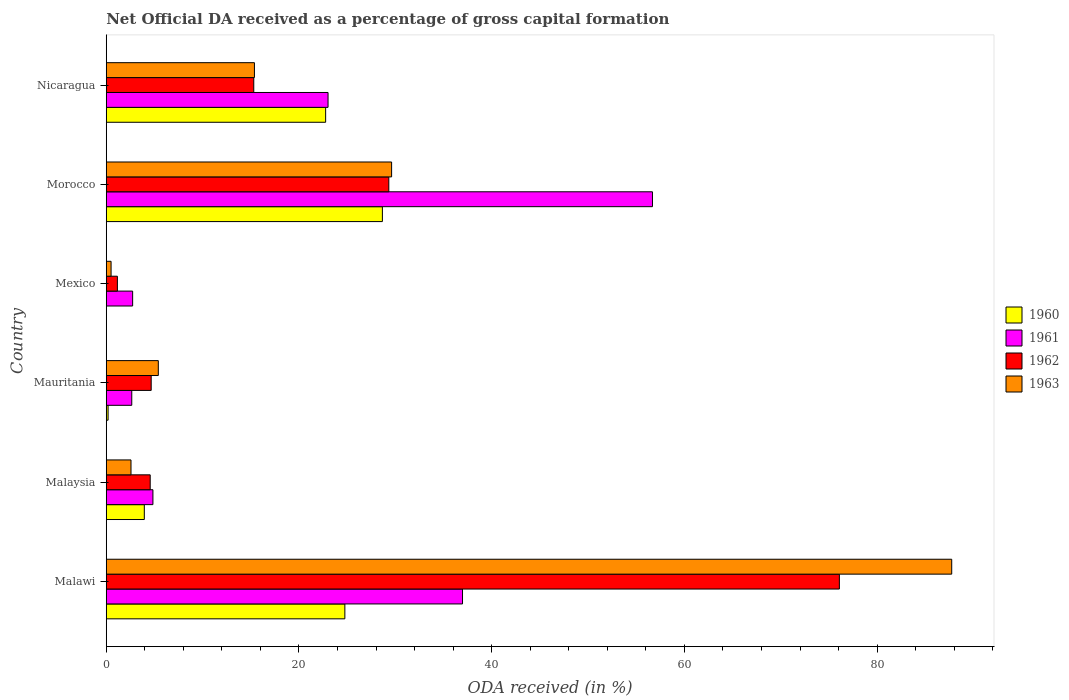How many different coloured bars are there?
Ensure brevity in your answer.  4. Are the number of bars per tick equal to the number of legend labels?
Give a very brief answer. No. What is the label of the 1st group of bars from the top?
Your answer should be very brief. Nicaragua. In how many cases, is the number of bars for a given country not equal to the number of legend labels?
Make the answer very short. 1. What is the net ODA received in 1963 in Malawi?
Provide a short and direct response. 87.74. Across all countries, what is the maximum net ODA received in 1961?
Your response must be concise. 56.69. Across all countries, what is the minimum net ODA received in 1962?
Your answer should be very brief. 1.16. In which country was the net ODA received in 1961 maximum?
Make the answer very short. Morocco. What is the total net ODA received in 1960 in the graph?
Your answer should be very brief. 80.33. What is the difference between the net ODA received in 1961 in Morocco and that in Nicaragua?
Offer a terse response. 33.67. What is the difference between the net ODA received in 1962 in Morocco and the net ODA received in 1961 in Mexico?
Provide a succinct answer. 26.59. What is the average net ODA received in 1960 per country?
Provide a succinct answer. 13.39. What is the difference between the net ODA received in 1962 and net ODA received in 1963 in Morocco?
Keep it short and to the point. -0.29. In how many countries, is the net ODA received in 1963 greater than 44 %?
Ensure brevity in your answer.  1. What is the ratio of the net ODA received in 1963 in Malawi to that in Mexico?
Your answer should be very brief. 174.93. Is the net ODA received in 1961 in Mexico less than that in Morocco?
Your answer should be compact. Yes. Is the difference between the net ODA received in 1962 in Mexico and Nicaragua greater than the difference between the net ODA received in 1963 in Mexico and Nicaragua?
Make the answer very short. Yes. What is the difference between the highest and the second highest net ODA received in 1963?
Provide a succinct answer. 58.13. What is the difference between the highest and the lowest net ODA received in 1962?
Ensure brevity in your answer.  74.92. Is it the case that in every country, the sum of the net ODA received in 1963 and net ODA received in 1962 is greater than the net ODA received in 1960?
Give a very brief answer. Yes. What is the difference between two consecutive major ticks on the X-axis?
Give a very brief answer. 20. Does the graph contain any zero values?
Your answer should be very brief. Yes. How many legend labels are there?
Your response must be concise. 4. What is the title of the graph?
Make the answer very short. Net Official DA received as a percentage of gross capital formation. What is the label or title of the X-axis?
Provide a short and direct response. ODA received (in %). What is the label or title of the Y-axis?
Offer a very short reply. Country. What is the ODA received (in %) in 1960 in Malawi?
Give a very brief answer. 24.76. What is the ODA received (in %) of 1961 in Malawi?
Make the answer very short. 36.97. What is the ODA received (in %) in 1962 in Malawi?
Your answer should be compact. 76.08. What is the ODA received (in %) of 1963 in Malawi?
Provide a short and direct response. 87.74. What is the ODA received (in %) of 1960 in Malaysia?
Your answer should be compact. 3.95. What is the ODA received (in %) of 1961 in Malaysia?
Provide a short and direct response. 4.84. What is the ODA received (in %) in 1962 in Malaysia?
Give a very brief answer. 4.56. What is the ODA received (in %) in 1963 in Malaysia?
Make the answer very short. 2.57. What is the ODA received (in %) in 1960 in Mauritania?
Offer a terse response. 0.19. What is the ODA received (in %) of 1961 in Mauritania?
Offer a very short reply. 2.65. What is the ODA received (in %) in 1962 in Mauritania?
Provide a short and direct response. 4.66. What is the ODA received (in %) in 1963 in Mauritania?
Provide a succinct answer. 5.4. What is the ODA received (in %) in 1961 in Mexico?
Provide a succinct answer. 2.74. What is the ODA received (in %) of 1962 in Mexico?
Provide a succinct answer. 1.16. What is the ODA received (in %) of 1963 in Mexico?
Ensure brevity in your answer.  0.5. What is the ODA received (in %) in 1960 in Morocco?
Ensure brevity in your answer.  28.66. What is the ODA received (in %) in 1961 in Morocco?
Provide a succinct answer. 56.69. What is the ODA received (in %) of 1962 in Morocco?
Make the answer very short. 29.32. What is the ODA received (in %) in 1963 in Morocco?
Your answer should be compact. 29.61. What is the ODA received (in %) of 1960 in Nicaragua?
Provide a short and direct response. 22.77. What is the ODA received (in %) of 1961 in Nicaragua?
Provide a succinct answer. 23.02. What is the ODA received (in %) in 1962 in Nicaragua?
Keep it short and to the point. 15.31. What is the ODA received (in %) in 1963 in Nicaragua?
Provide a short and direct response. 15.38. Across all countries, what is the maximum ODA received (in %) in 1960?
Offer a very short reply. 28.66. Across all countries, what is the maximum ODA received (in %) of 1961?
Keep it short and to the point. 56.69. Across all countries, what is the maximum ODA received (in %) of 1962?
Your answer should be very brief. 76.08. Across all countries, what is the maximum ODA received (in %) of 1963?
Provide a short and direct response. 87.74. Across all countries, what is the minimum ODA received (in %) in 1960?
Offer a terse response. 0. Across all countries, what is the minimum ODA received (in %) in 1961?
Provide a succinct answer. 2.65. Across all countries, what is the minimum ODA received (in %) of 1962?
Offer a very short reply. 1.16. Across all countries, what is the minimum ODA received (in %) of 1963?
Give a very brief answer. 0.5. What is the total ODA received (in %) of 1960 in the graph?
Ensure brevity in your answer.  80.33. What is the total ODA received (in %) of 1961 in the graph?
Make the answer very short. 126.91. What is the total ODA received (in %) of 1962 in the graph?
Offer a very short reply. 131.1. What is the total ODA received (in %) of 1963 in the graph?
Offer a very short reply. 141.21. What is the difference between the ODA received (in %) in 1960 in Malawi and that in Malaysia?
Offer a terse response. 20.81. What is the difference between the ODA received (in %) in 1961 in Malawi and that in Malaysia?
Offer a terse response. 32.13. What is the difference between the ODA received (in %) of 1962 in Malawi and that in Malaysia?
Give a very brief answer. 71.52. What is the difference between the ODA received (in %) in 1963 in Malawi and that in Malaysia?
Provide a short and direct response. 85.17. What is the difference between the ODA received (in %) in 1960 in Malawi and that in Mauritania?
Your answer should be compact. 24.57. What is the difference between the ODA received (in %) in 1961 in Malawi and that in Mauritania?
Offer a very short reply. 34.32. What is the difference between the ODA received (in %) in 1962 in Malawi and that in Mauritania?
Provide a succinct answer. 71.42. What is the difference between the ODA received (in %) of 1963 in Malawi and that in Mauritania?
Your answer should be very brief. 82.34. What is the difference between the ODA received (in %) in 1961 in Malawi and that in Mexico?
Make the answer very short. 34.23. What is the difference between the ODA received (in %) of 1962 in Malawi and that in Mexico?
Your response must be concise. 74.92. What is the difference between the ODA received (in %) in 1963 in Malawi and that in Mexico?
Offer a terse response. 87.24. What is the difference between the ODA received (in %) in 1960 in Malawi and that in Morocco?
Give a very brief answer. -3.9. What is the difference between the ODA received (in %) in 1961 in Malawi and that in Morocco?
Provide a short and direct response. -19.71. What is the difference between the ODA received (in %) in 1962 in Malawi and that in Morocco?
Provide a short and direct response. 46.76. What is the difference between the ODA received (in %) of 1963 in Malawi and that in Morocco?
Your answer should be compact. 58.13. What is the difference between the ODA received (in %) in 1960 in Malawi and that in Nicaragua?
Your response must be concise. 1.99. What is the difference between the ODA received (in %) in 1961 in Malawi and that in Nicaragua?
Keep it short and to the point. 13.96. What is the difference between the ODA received (in %) of 1962 in Malawi and that in Nicaragua?
Provide a succinct answer. 60.77. What is the difference between the ODA received (in %) of 1963 in Malawi and that in Nicaragua?
Offer a very short reply. 72.36. What is the difference between the ODA received (in %) of 1960 in Malaysia and that in Mauritania?
Offer a terse response. 3.76. What is the difference between the ODA received (in %) of 1961 in Malaysia and that in Mauritania?
Keep it short and to the point. 2.2. What is the difference between the ODA received (in %) in 1962 in Malaysia and that in Mauritania?
Your response must be concise. -0.1. What is the difference between the ODA received (in %) of 1963 in Malaysia and that in Mauritania?
Offer a very short reply. -2.83. What is the difference between the ODA received (in %) of 1961 in Malaysia and that in Mexico?
Your answer should be very brief. 2.11. What is the difference between the ODA received (in %) in 1962 in Malaysia and that in Mexico?
Ensure brevity in your answer.  3.4. What is the difference between the ODA received (in %) of 1963 in Malaysia and that in Mexico?
Offer a terse response. 2.07. What is the difference between the ODA received (in %) of 1960 in Malaysia and that in Morocco?
Your response must be concise. -24.71. What is the difference between the ODA received (in %) of 1961 in Malaysia and that in Morocco?
Your response must be concise. -51.84. What is the difference between the ODA received (in %) in 1962 in Malaysia and that in Morocco?
Your answer should be very brief. -24.76. What is the difference between the ODA received (in %) in 1963 in Malaysia and that in Morocco?
Provide a short and direct response. -27.04. What is the difference between the ODA received (in %) of 1960 in Malaysia and that in Nicaragua?
Provide a short and direct response. -18.82. What is the difference between the ODA received (in %) of 1961 in Malaysia and that in Nicaragua?
Your answer should be very brief. -18.17. What is the difference between the ODA received (in %) in 1962 in Malaysia and that in Nicaragua?
Ensure brevity in your answer.  -10.75. What is the difference between the ODA received (in %) in 1963 in Malaysia and that in Nicaragua?
Offer a very short reply. -12.81. What is the difference between the ODA received (in %) in 1961 in Mauritania and that in Mexico?
Make the answer very short. -0.09. What is the difference between the ODA received (in %) of 1962 in Mauritania and that in Mexico?
Give a very brief answer. 3.51. What is the difference between the ODA received (in %) in 1963 in Mauritania and that in Mexico?
Provide a short and direct response. 4.9. What is the difference between the ODA received (in %) of 1960 in Mauritania and that in Morocco?
Keep it short and to the point. -28.47. What is the difference between the ODA received (in %) in 1961 in Mauritania and that in Morocco?
Give a very brief answer. -54.04. What is the difference between the ODA received (in %) of 1962 in Mauritania and that in Morocco?
Give a very brief answer. -24.66. What is the difference between the ODA received (in %) of 1963 in Mauritania and that in Morocco?
Provide a succinct answer. -24.21. What is the difference between the ODA received (in %) in 1960 in Mauritania and that in Nicaragua?
Your answer should be compact. -22.58. What is the difference between the ODA received (in %) of 1961 in Mauritania and that in Nicaragua?
Offer a terse response. -20.37. What is the difference between the ODA received (in %) in 1962 in Mauritania and that in Nicaragua?
Offer a very short reply. -10.64. What is the difference between the ODA received (in %) of 1963 in Mauritania and that in Nicaragua?
Provide a succinct answer. -9.97. What is the difference between the ODA received (in %) in 1961 in Mexico and that in Morocco?
Provide a short and direct response. -53.95. What is the difference between the ODA received (in %) in 1962 in Mexico and that in Morocco?
Offer a terse response. -28.17. What is the difference between the ODA received (in %) in 1963 in Mexico and that in Morocco?
Provide a short and direct response. -29.11. What is the difference between the ODA received (in %) of 1961 in Mexico and that in Nicaragua?
Give a very brief answer. -20.28. What is the difference between the ODA received (in %) of 1962 in Mexico and that in Nicaragua?
Provide a succinct answer. -14.15. What is the difference between the ODA received (in %) in 1963 in Mexico and that in Nicaragua?
Provide a short and direct response. -14.88. What is the difference between the ODA received (in %) of 1960 in Morocco and that in Nicaragua?
Make the answer very short. 5.89. What is the difference between the ODA received (in %) of 1961 in Morocco and that in Nicaragua?
Keep it short and to the point. 33.67. What is the difference between the ODA received (in %) of 1962 in Morocco and that in Nicaragua?
Your answer should be compact. 14.02. What is the difference between the ODA received (in %) in 1963 in Morocco and that in Nicaragua?
Ensure brevity in your answer.  14.23. What is the difference between the ODA received (in %) in 1960 in Malawi and the ODA received (in %) in 1961 in Malaysia?
Keep it short and to the point. 19.92. What is the difference between the ODA received (in %) in 1960 in Malawi and the ODA received (in %) in 1962 in Malaysia?
Make the answer very short. 20.2. What is the difference between the ODA received (in %) in 1960 in Malawi and the ODA received (in %) in 1963 in Malaysia?
Make the answer very short. 22.19. What is the difference between the ODA received (in %) in 1961 in Malawi and the ODA received (in %) in 1962 in Malaysia?
Ensure brevity in your answer.  32.41. What is the difference between the ODA received (in %) in 1961 in Malawi and the ODA received (in %) in 1963 in Malaysia?
Your answer should be very brief. 34.4. What is the difference between the ODA received (in %) of 1962 in Malawi and the ODA received (in %) of 1963 in Malaysia?
Provide a succinct answer. 73.51. What is the difference between the ODA received (in %) in 1960 in Malawi and the ODA received (in %) in 1961 in Mauritania?
Your answer should be very brief. 22.11. What is the difference between the ODA received (in %) in 1960 in Malawi and the ODA received (in %) in 1962 in Mauritania?
Make the answer very short. 20.1. What is the difference between the ODA received (in %) in 1960 in Malawi and the ODA received (in %) in 1963 in Mauritania?
Your answer should be compact. 19.36. What is the difference between the ODA received (in %) in 1961 in Malawi and the ODA received (in %) in 1962 in Mauritania?
Keep it short and to the point. 32.31. What is the difference between the ODA received (in %) of 1961 in Malawi and the ODA received (in %) of 1963 in Mauritania?
Offer a terse response. 31.57. What is the difference between the ODA received (in %) in 1962 in Malawi and the ODA received (in %) in 1963 in Mauritania?
Provide a short and direct response. 70.68. What is the difference between the ODA received (in %) in 1960 in Malawi and the ODA received (in %) in 1961 in Mexico?
Your answer should be very brief. 22.02. What is the difference between the ODA received (in %) of 1960 in Malawi and the ODA received (in %) of 1962 in Mexico?
Provide a succinct answer. 23.6. What is the difference between the ODA received (in %) in 1960 in Malawi and the ODA received (in %) in 1963 in Mexico?
Ensure brevity in your answer.  24.26. What is the difference between the ODA received (in %) of 1961 in Malawi and the ODA received (in %) of 1962 in Mexico?
Offer a very short reply. 35.82. What is the difference between the ODA received (in %) of 1961 in Malawi and the ODA received (in %) of 1963 in Mexico?
Your answer should be compact. 36.47. What is the difference between the ODA received (in %) of 1962 in Malawi and the ODA received (in %) of 1963 in Mexico?
Offer a terse response. 75.58. What is the difference between the ODA received (in %) in 1960 in Malawi and the ODA received (in %) in 1961 in Morocco?
Make the answer very short. -31.92. What is the difference between the ODA received (in %) in 1960 in Malawi and the ODA received (in %) in 1962 in Morocco?
Offer a very short reply. -4.56. What is the difference between the ODA received (in %) of 1960 in Malawi and the ODA received (in %) of 1963 in Morocco?
Provide a succinct answer. -4.85. What is the difference between the ODA received (in %) of 1961 in Malawi and the ODA received (in %) of 1962 in Morocco?
Your answer should be very brief. 7.65. What is the difference between the ODA received (in %) in 1961 in Malawi and the ODA received (in %) in 1963 in Morocco?
Keep it short and to the point. 7.36. What is the difference between the ODA received (in %) in 1962 in Malawi and the ODA received (in %) in 1963 in Morocco?
Ensure brevity in your answer.  46.47. What is the difference between the ODA received (in %) of 1960 in Malawi and the ODA received (in %) of 1961 in Nicaragua?
Keep it short and to the point. 1.75. What is the difference between the ODA received (in %) in 1960 in Malawi and the ODA received (in %) in 1962 in Nicaragua?
Offer a very short reply. 9.45. What is the difference between the ODA received (in %) of 1960 in Malawi and the ODA received (in %) of 1963 in Nicaragua?
Offer a terse response. 9.38. What is the difference between the ODA received (in %) in 1961 in Malawi and the ODA received (in %) in 1962 in Nicaragua?
Your answer should be very brief. 21.66. What is the difference between the ODA received (in %) of 1961 in Malawi and the ODA received (in %) of 1963 in Nicaragua?
Your answer should be very brief. 21.59. What is the difference between the ODA received (in %) in 1962 in Malawi and the ODA received (in %) in 1963 in Nicaragua?
Make the answer very short. 60.7. What is the difference between the ODA received (in %) of 1960 in Malaysia and the ODA received (in %) of 1961 in Mauritania?
Your response must be concise. 1.3. What is the difference between the ODA received (in %) in 1960 in Malaysia and the ODA received (in %) in 1962 in Mauritania?
Offer a very short reply. -0.71. What is the difference between the ODA received (in %) of 1960 in Malaysia and the ODA received (in %) of 1963 in Mauritania?
Keep it short and to the point. -1.45. What is the difference between the ODA received (in %) in 1961 in Malaysia and the ODA received (in %) in 1962 in Mauritania?
Provide a succinct answer. 0.18. What is the difference between the ODA received (in %) in 1961 in Malaysia and the ODA received (in %) in 1963 in Mauritania?
Provide a short and direct response. -0.56. What is the difference between the ODA received (in %) of 1962 in Malaysia and the ODA received (in %) of 1963 in Mauritania?
Your response must be concise. -0.84. What is the difference between the ODA received (in %) of 1960 in Malaysia and the ODA received (in %) of 1961 in Mexico?
Your answer should be compact. 1.21. What is the difference between the ODA received (in %) in 1960 in Malaysia and the ODA received (in %) in 1962 in Mexico?
Your answer should be very brief. 2.79. What is the difference between the ODA received (in %) of 1960 in Malaysia and the ODA received (in %) of 1963 in Mexico?
Provide a short and direct response. 3.45. What is the difference between the ODA received (in %) of 1961 in Malaysia and the ODA received (in %) of 1962 in Mexico?
Offer a terse response. 3.69. What is the difference between the ODA received (in %) of 1961 in Malaysia and the ODA received (in %) of 1963 in Mexico?
Offer a terse response. 4.34. What is the difference between the ODA received (in %) in 1962 in Malaysia and the ODA received (in %) in 1963 in Mexico?
Ensure brevity in your answer.  4.06. What is the difference between the ODA received (in %) in 1960 in Malaysia and the ODA received (in %) in 1961 in Morocco?
Your response must be concise. -52.73. What is the difference between the ODA received (in %) of 1960 in Malaysia and the ODA received (in %) of 1962 in Morocco?
Ensure brevity in your answer.  -25.37. What is the difference between the ODA received (in %) of 1960 in Malaysia and the ODA received (in %) of 1963 in Morocco?
Make the answer very short. -25.66. What is the difference between the ODA received (in %) in 1961 in Malaysia and the ODA received (in %) in 1962 in Morocco?
Offer a terse response. -24.48. What is the difference between the ODA received (in %) in 1961 in Malaysia and the ODA received (in %) in 1963 in Morocco?
Offer a terse response. -24.77. What is the difference between the ODA received (in %) in 1962 in Malaysia and the ODA received (in %) in 1963 in Morocco?
Your answer should be compact. -25.05. What is the difference between the ODA received (in %) of 1960 in Malaysia and the ODA received (in %) of 1961 in Nicaragua?
Offer a very short reply. -19.07. What is the difference between the ODA received (in %) in 1960 in Malaysia and the ODA received (in %) in 1962 in Nicaragua?
Provide a short and direct response. -11.36. What is the difference between the ODA received (in %) in 1960 in Malaysia and the ODA received (in %) in 1963 in Nicaragua?
Make the answer very short. -11.43. What is the difference between the ODA received (in %) in 1961 in Malaysia and the ODA received (in %) in 1962 in Nicaragua?
Offer a very short reply. -10.46. What is the difference between the ODA received (in %) in 1961 in Malaysia and the ODA received (in %) in 1963 in Nicaragua?
Provide a succinct answer. -10.53. What is the difference between the ODA received (in %) of 1962 in Malaysia and the ODA received (in %) of 1963 in Nicaragua?
Ensure brevity in your answer.  -10.82. What is the difference between the ODA received (in %) of 1960 in Mauritania and the ODA received (in %) of 1961 in Mexico?
Your answer should be very brief. -2.55. What is the difference between the ODA received (in %) in 1960 in Mauritania and the ODA received (in %) in 1962 in Mexico?
Offer a very short reply. -0.97. What is the difference between the ODA received (in %) of 1960 in Mauritania and the ODA received (in %) of 1963 in Mexico?
Make the answer very short. -0.31. What is the difference between the ODA received (in %) of 1961 in Mauritania and the ODA received (in %) of 1962 in Mexico?
Offer a very short reply. 1.49. What is the difference between the ODA received (in %) in 1961 in Mauritania and the ODA received (in %) in 1963 in Mexico?
Keep it short and to the point. 2.15. What is the difference between the ODA received (in %) in 1962 in Mauritania and the ODA received (in %) in 1963 in Mexico?
Your answer should be compact. 4.16. What is the difference between the ODA received (in %) in 1960 in Mauritania and the ODA received (in %) in 1961 in Morocco?
Make the answer very short. -56.49. What is the difference between the ODA received (in %) of 1960 in Mauritania and the ODA received (in %) of 1962 in Morocco?
Offer a very short reply. -29.13. What is the difference between the ODA received (in %) in 1960 in Mauritania and the ODA received (in %) in 1963 in Morocco?
Offer a very short reply. -29.42. What is the difference between the ODA received (in %) of 1961 in Mauritania and the ODA received (in %) of 1962 in Morocco?
Your answer should be very brief. -26.68. What is the difference between the ODA received (in %) in 1961 in Mauritania and the ODA received (in %) in 1963 in Morocco?
Keep it short and to the point. -26.96. What is the difference between the ODA received (in %) in 1962 in Mauritania and the ODA received (in %) in 1963 in Morocco?
Give a very brief answer. -24.95. What is the difference between the ODA received (in %) of 1960 in Mauritania and the ODA received (in %) of 1961 in Nicaragua?
Your answer should be very brief. -22.83. What is the difference between the ODA received (in %) in 1960 in Mauritania and the ODA received (in %) in 1962 in Nicaragua?
Keep it short and to the point. -15.12. What is the difference between the ODA received (in %) in 1960 in Mauritania and the ODA received (in %) in 1963 in Nicaragua?
Keep it short and to the point. -15.19. What is the difference between the ODA received (in %) of 1961 in Mauritania and the ODA received (in %) of 1962 in Nicaragua?
Your answer should be very brief. -12.66. What is the difference between the ODA received (in %) of 1961 in Mauritania and the ODA received (in %) of 1963 in Nicaragua?
Your response must be concise. -12.73. What is the difference between the ODA received (in %) of 1962 in Mauritania and the ODA received (in %) of 1963 in Nicaragua?
Offer a terse response. -10.71. What is the difference between the ODA received (in %) in 1961 in Mexico and the ODA received (in %) in 1962 in Morocco?
Make the answer very short. -26.59. What is the difference between the ODA received (in %) in 1961 in Mexico and the ODA received (in %) in 1963 in Morocco?
Ensure brevity in your answer.  -26.87. What is the difference between the ODA received (in %) of 1962 in Mexico and the ODA received (in %) of 1963 in Morocco?
Your response must be concise. -28.46. What is the difference between the ODA received (in %) in 1961 in Mexico and the ODA received (in %) in 1962 in Nicaragua?
Provide a short and direct response. -12.57. What is the difference between the ODA received (in %) of 1961 in Mexico and the ODA received (in %) of 1963 in Nicaragua?
Provide a short and direct response. -12.64. What is the difference between the ODA received (in %) of 1962 in Mexico and the ODA received (in %) of 1963 in Nicaragua?
Offer a terse response. -14.22. What is the difference between the ODA received (in %) in 1960 in Morocco and the ODA received (in %) in 1961 in Nicaragua?
Ensure brevity in your answer.  5.64. What is the difference between the ODA received (in %) of 1960 in Morocco and the ODA received (in %) of 1962 in Nicaragua?
Provide a short and direct response. 13.35. What is the difference between the ODA received (in %) in 1960 in Morocco and the ODA received (in %) in 1963 in Nicaragua?
Provide a short and direct response. 13.28. What is the difference between the ODA received (in %) of 1961 in Morocco and the ODA received (in %) of 1962 in Nicaragua?
Your response must be concise. 41.38. What is the difference between the ODA received (in %) of 1961 in Morocco and the ODA received (in %) of 1963 in Nicaragua?
Provide a succinct answer. 41.31. What is the difference between the ODA received (in %) of 1962 in Morocco and the ODA received (in %) of 1963 in Nicaragua?
Your response must be concise. 13.95. What is the average ODA received (in %) of 1960 per country?
Keep it short and to the point. 13.39. What is the average ODA received (in %) in 1961 per country?
Offer a very short reply. 21.15. What is the average ODA received (in %) in 1962 per country?
Ensure brevity in your answer.  21.85. What is the average ODA received (in %) of 1963 per country?
Your answer should be compact. 23.53. What is the difference between the ODA received (in %) in 1960 and ODA received (in %) in 1961 in Malawi?
Your answer should be compact. -12.21. What is the difference between the ODA received (in %) of 1960 and ODA received (in %) of 1962 in Malawi?
Provide a short and direct response. -51.32. What is the difference between the ODA received (in %) in 1960 and ODA received (in %) in 1963 in Malawi?
Your response must be concise. -62.98. What is the difference between the ODA received (in %) in 1961 and ODA received (in %) in 1962 in Malawi?
Make the answer very short. -39.11. What is the difference between the ODA received (in %) in 1961 and ODA received (in %) in 1963 in Malawi?
Ensure brevity in your answer.  -50.77. What is the difference between the ODA received (in %) in 1962 and ODA received (in %) in 1963 in Malawi?
Your response must be concise. -11.66. What is the difference between the ODA received (in %) of 1960 and ODA received (in %) of 1961 in Malaysia?
Ensure brevity in your answer.  -0.89. What is the difference between the ODA received (in %) of 1960 and ODA received (in %) of 1962 in Malaysia?
Your answer should be very brief. -0.61. What is the difference between the ODA received (in %) in 1960 and ODA received (in %) in 1963 in Malaysia?
Offer a terse response. 1.38. What is the difference between the ODA received (in %) in 1961 and ODA received (in %) in 1962 in Malaysia?
Offer a very short reply. 0.28. What is the difference between the ODA received (in %) of 1961 and ODA received (in %) of 1963 in Malaysia?
Ensure brevity in your answer.  2.28. What is the difference between the ODA received (in %) in 1962 and ODA received (in %) in 1963 in Malaysia?
Give a very brief answer. 1.99. What is the difference between the ODA received (in %) in 1960 and ODA received (in %) in 1961 in Mauritania?
Give a very brief answer. -2.46. What is the difference between the ODA received (in %) of 1960 and ODA received (in %) of 1962 in Mauritania?
Ensure brevity in your answer.  -4.47. What is the difference between the ODA received (in %) in 1960 and ODA received (in %) in 1963 in Mauritania?
Provide a succinct answer. -5.21. What is the difference between the ODA received (in %) of 1961 and ODA received (in %) of 1962 in Mauritania?
Offer a terse response. -2.02. What is the difference between the ODA received (in %) in 1961 and ODA received (in %) in 1963 in Mauritania?
Offer a terse response. -2.75. What is the difference between the ODA received (in %) of 1962 and ODA received (in %) of 1963 in Mauritania?
Ensure brevity in your answer.  -0.74. What is the difference between the ODA received (in %) in 1961 and ODA received (in %) in 1962 in Mexico?
Make the answer very short. 1.58. What is the difference between the ODA received (in %) in 1961 and ODA received (in %) in 1963 in Mexico?
Keep it short and to the point. 2.24. What is the difference between the ODA received (in %) in 1962 and ODA received (in %) in 1963 in Mexico?
Offer a very short reply. 0.66. What is the difference between the ODA received (in %) of 1960 and ODA received (in %) of 1961 in Morocco?
Provide a succinct answer. -28.03. What is the difference between the ODA received (in %) in 1960 and ODA received (in %) in 1962 in Morocco?
Offer a terse response. -0.67. What is the difference between the ODA received (in %) of 1960 and ODA received (in %) of 1963 in Morocco?
Provide a short and direct response. -0.96. What is the difference between the ODA received (in %) of 1961 and ODA received (in %) of 1962 in Morocco?
Make the answer very short. 27.36. What is the difference between the ODA received (in %) in 1961 and ODA received (in %) in 1963 in Morocco?
Ensure brevity in your answer.  27.07. What is the difference between the ODA received (in %) of 1962 and ODA received (in %) of 1963 in Morocco?
Provide a short and direct response. -0.29. What is the difference between the ODA received (in %) in 1960 and ODA received (in %) in 1961 in Nicaragua?
Offer a terse response. -0.25. What is the difference between the ODA received (in %) of 1960 and ODA received (in %) of 1962 in Nicaragua?
Your response must be concise. 7.46. What is the difference between the ODA received (in %) of 1960 and ODA received (in %) of 1963 in Nicaragua?
Make the answer very short. 7.39. What is the difference between the ODA received (in %) in 1961 and ODA received (in %) in 1962 in Nicaragua?
Provide a short and direct response. 7.71. What is the difference between the ODA received (in %) in 1961 and ODA received (in %) in 1963 in Nicaragua?
Your answer should be compact. 7.64. What is the difference between the ODA received (in %) of 1962 and ODA received (in %) of 1963 in Nicaragua?
Your response must be concise. -0.07. What is the ratio of the ODA received (in %) of 1960 in Malawi to that in Malaysia?
Your answer should be very brief. 6.27. What is the ratio of the ODA received (in %) of 1961 in Malawi to that in Malaysia?
Ensure brevity in your answer.  7.63. What is the ratio of the ODA received (in %) of 1962 in Malawi to that in Malaysia?
Provide a short and direct response. 16.68. What is the ratio of the ODA received (in %) of 1963 in Malawi to that in Malaysia?
Make the answer very short. 34.15. What is the ratio of the ODA received (in %) of 1960 in Malawi to that in Mauritania?
Provide a succinct answer. 129.73. What is the ratio of the ODA received (in %) of 1961 in Malawi to that in Mauritania?
Your response must be concise. 13.96. What is the ratio of the ODA received (in %) of 1962 in Malawi to that in Mauritania?
Offer a very short reply. 16.31. What is the ratio of the ODA received (in %) in 1963 in Malawi to that in Mauritania?
Provide a short and direct response. 16.24. What is the ratio of the ODA received (in %) in 1961 in Malawi to that in Mexico?
Offer a terse response. 13.5. What is the ratio of the ODA received (in %) of 1962 in Malawi to that in Mexico?
Provide a short and direct response. 65.75. What is the ratio of the ODA received (in %) in 1963 in Malawi to that in Mexico?
Offer a terse response. 174.93. What is the ratio of the ODA received (in %) of 1960 in Malawi to that in Morocco?
Offer a terse response. 0.86. What is the ratio of the ODA received (in %) in 1961 in Malawi to that in Morocco?
Offer a very short reply. 0.65. What is the ratio of the ODA received (in %) in 1962 in Malawi to that in Morocco?
Offer a terse response. 2.59. What is the ratio of the ODA received (in %) in 1963 in Malawi to that in Morocco?
Offer a terse response. 2.96. What is the ratio of the ODA received (in %) of 1960 in Malawi to that in Nicaragua?
Make the answer very short. 1.09. What is the ratio of the ODA received (in %) in 1961 in Malawi to that in Nicaragua?
Your answer should be very brief. 1.61. What is the ratio of the ODA received (in %) in 1962 in Malawi to that in Nicaragua?
Provide a succinct answer. 4.97. What is the ratio of the ODA received (in %) in 1963 in Malawi to that in Nicaragua?
Offer a terse response. 5.71. What is the ratio of the ODA received (in %) in 1960 in Malaysia to that in Mauritania?
Offer a terse response. 20.7. What is the ratio of the ODA received (in %) in 1961 in Malaysia to that in Mauritania?
Make the answer very short. 1.83. What is the ratio of the ODA received (in %) of 1962 in Malaysia to that in Mauritania?
Your response must be concise. 0.98. What is the ratio of the ODA received (in %) in 1963 in Malaysia to that in Mauritania?
Your response must be concise. 0.48. What is the ratio of the ODA received (in %) in 1961 in Malaysia to that in Mexico?
Ensure brevity in your answer.  1.77. What is the ratio of the ODA received (in %) of 1962 in Malaysia to that in Mexico?
Your answer should be very brief. 3.94. What is the ratio of the ODA received (in %) in 1963 in Malaysia to that in Mexico?
Your response must be concise. 5.12. What is the ratio of the ODA received (in %) in 1960 in Malaysia to that in Morocco?
Make the answer very short. 0.14. What is the ratio of the ODA received (in %) of 1961 in Malaysia to that in Morocco?
Provide a succinct answer. 0.09. What is the ratio of the ODA received (in %) in 1962 in Malaysia to that in Morocco?
Make the answer very short. 0.16. What is the ratio of the ODA received (in %) in 1963 in Malaysia to that in Morocco?
Your answer should be very brief. 0.09. What is the ratio of the ODA received (in %) of 1960 in Malaysia to that in Nicaragua?
Your answer should be very brief. 0.17. What is the ratio of the ODA received (in %) of 1961 in Malaysia to that in Nicaragua?
Provide a short and direct response. 0.21. What is the ratio of the ODA received (in %) of 1962 in Malaysia to that in Nicaragua?
Ensure brevity in your answer.  0.3. What is the ratio of the ODA received (in %) in 1963 in Malaysia to that in Nicaragua?
Ensure brevity in your answer.  0.17. What is the ratio of the ODA received (in %) of 1961 in Mauritania to that in Mexico?
Offer a very short reply. 0.97. What is the ratio of the ODA received (in %) of 1962 in Mauritania to that in Mexico?
Provide a short and direct response. 4.03. What is the ratio of the ODA received (in %) of 1963 in Mauritania to that in Mexico?
Your response must be concise. 10.77. What is the ratio of the ODA received (in %) in 1960 in Mauritania to that in Morocco?
Your response must be concise. 0.01. What is the ratio of the ODA received (in %) in 1961 in Mauritania to that in Morocco?
Give a very brief answer. 0.05. What is the ratio of the ODA received (in %) in 1962 in Mauritania to that in Morocco?
Provide a short and direct response. 0.16. What is the ratio of the ODA received (in %) of 1963 in Mauritania to that in Morocco?
Make the answer very short. 0.18. What is the ratio of the ODA received (in %) in 1960 in Mauritania to that in Nicaragua?
Keep it short and to the point. 0.01. What is the ratio of the ODA received (in %) of 1961 in Mauritania to that in Nicaragua?
Ensure brevity in your answer.  0.12. What is the ratio of the ODA received (in %) of 1962 in Mauritania to that in Nicaragua?
Give a very brief answer. 0.3. What is the ratio of the ODA received (in %) of 1963 in Mauritania to that in Nicaragua?
Make the answer very short. 0.35. What is the ratio of the ODA received (in %) in 1961 in Mexico to that in Morocco?
Provide a short and direct response. 0.05. What is the ratio of the ODA received (in %) of 1962 in Mexico to that in Morocco?
Offer a very short reply. 0.04. What is the ratio of the ODA received (in %) in 1963 in Mexico to that in Morocco?
Offer a terse response. 0.02. What is the ratio of the ODA received (in %) in 1961 in Mexico to that in Nicaragua?
Your answer should be very brief. 0.12. What is the ratio of the ODA received (in %) of 1962 in Mexico to that in Nicaragua?
Keep it short and to the point. 0.08. What is the ratio of the ODA received (in %) of 1963 in Mexico to that in Nicaragua?
Keep it short and to the point. 0.03. What is the ratio of the ODA received (in %) in 1960 in Morocco to that in Nicaragua?
Your answer should be very brief. 1.26. What is the ratio of the ODA received (in %) of 1961 in Morocco to that in Nicaragua?
Ensure brevity in your answer.  2.46. What is the ratio of the ODA received (in %) of 1962 in Morocco to that in Nicaragua?
Provide a short and direct response. 1.92. What is the ratio of the ODA received (in %) of 1963 in Morocco to that in Nicaragua?
Offer a very short reply. 1.93. What is the difference between the highest and the second highest ODA received (in %) of 1960?
Your answer should be very brief. 3.9. What is the difference between the highest and the second highest ODA received (in %) in 1961?
Make the answer very short. 19.71. What is the difference between the highest and the second highest ODA received (in %) of 1962?
Ensure brevity in your answer.  46.76. What is the difference between the highest and the second highest ODA received (in %) of 1963?
Your answer should be very brief. 58.13. What is the difference between the highest and the lowest ODA received (in %) of 1960?
Your answer should be compact. 28.66. What is the difference between the highest and the lowest ODA received (in %) of 1961?
Provide a succinct answer. 54.04. What is the difference between the highest and the lowest ODA received (in %) of 1962?
Your answer should be very brief. 74.92. What is the difference between the highest and the lowest ODA received (in %) of 1963?
Give a very brief answer. 87.24. 